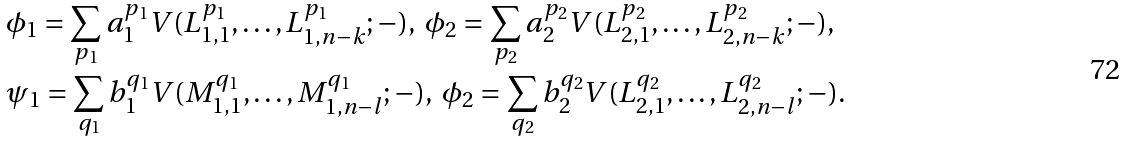Convert formula to latex. <formula><loc_0><loc_0><loc_500><loc_500>& \phi _ { 1 } = \sum _ { p _ { 1 } } a _ { 1 } ^ { p _ { 1 } } V ( L _ { 1 , 1 } ^ { p _ { 1 } } , \dots , L _ { 1 , n - k } ^ { p _ { 1 } } ; - ) , \ \phi _ { 2 } = \sum _ { p _ { 2 } } a _ { 2 } ^ { p _ { 2 } } V ( L _ { 2 , 1 } ^ { p _ { 2 } } , \dots , L _ { 2 , n - k } ^ { p _ { 2 } } ; - ) , \\ & \psi _ { 1 } = \sum _ { q _ { 1 } } b _ { 1 } ^ { q _ { 1 } } V ( M _ { 1 , 1 } ^ { q _ { 1 } } , \dots , M _ { 1 , n - l } ^ { q _ { 1 } } ; - ) , \ \phi _ { 2 } = \sum _ { q _ { 2 } } b _ { 2 } ^ { q _ { 2 } } V ( L _ { 2 , 1 } ^ { q _ { 2 } } , \dots , L _ { 2 , n - l } ^ { q _ { 2 } } ; - ) .</formula> 